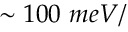Convert formula to latex. <formula><loc_0><loc_0><loc_500><loc_500>\sim 1 0 0 \ m e V / \</formula> 